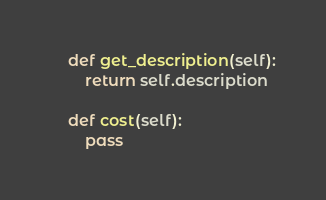<code> <loc_0><loc_0><loc_500><loc_500><_Python_>
    def get_description(self):
        return self.description

    def cost(self):
        pass
</code> 